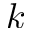<formula> <loc_0><loc_0><loc_500><loc_500>k</formula> 